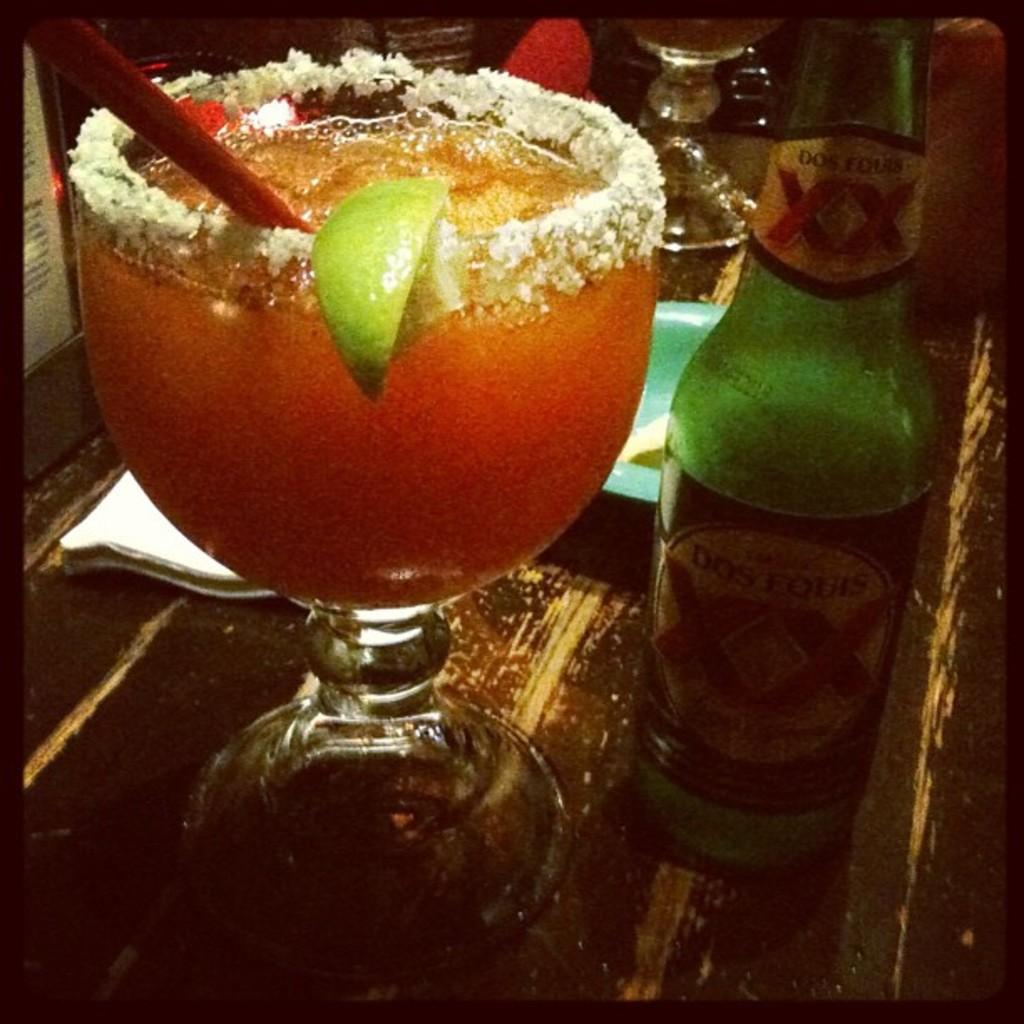<image>
Share a concise interpretation of the image provided. A Dos Equis green colored bottle of beer sitting on a counter next to a margarita. 